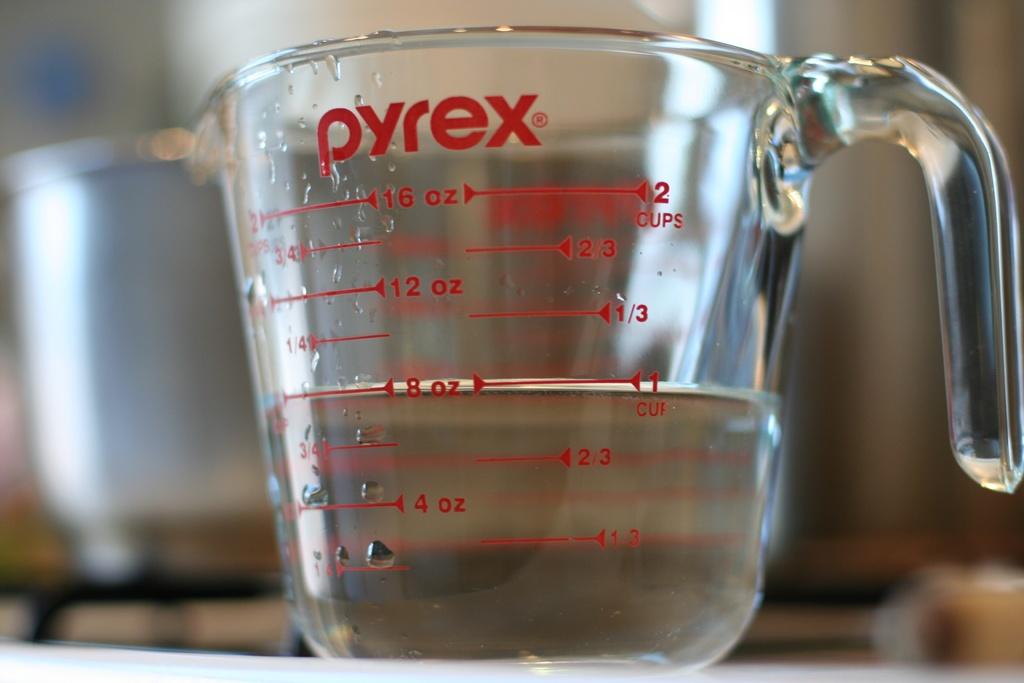What's the biggest measurements for ounces?
Keep it short and to the point. 16. 